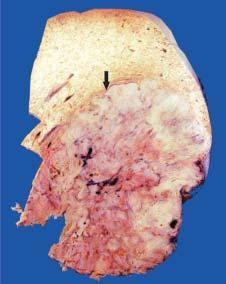what does rest of the hepatic parenchyma in the upper part of the picture show?
Answer the question using a single word or phrase. Many nodules of variable sizes 